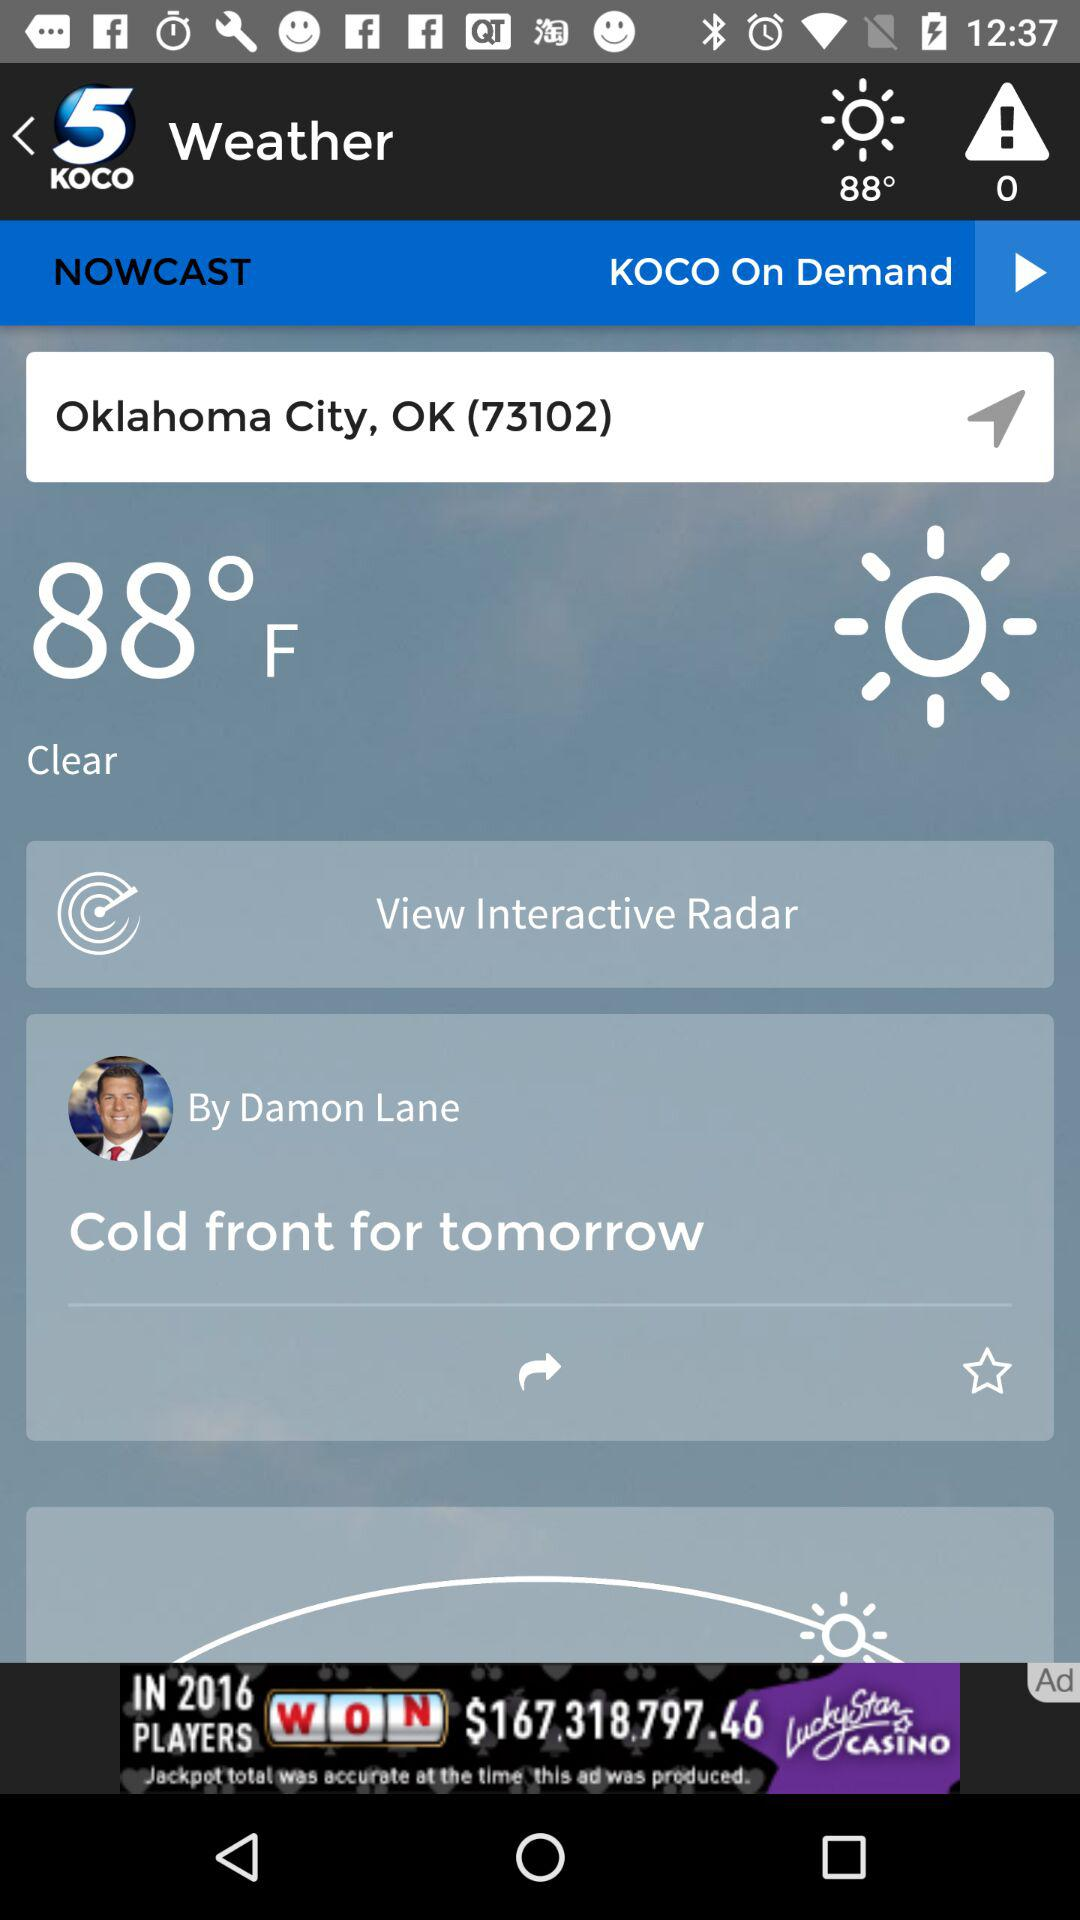What is the weather forecast? The weather is clear. 